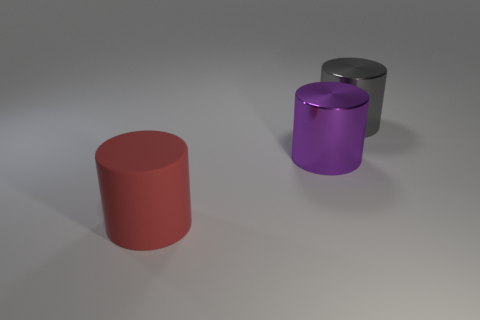Can you describe the colors and shapes present in this image? Certainly! There are three cylindrical objects in the image. Starting from the left, the first one is red with a matte finish, the middle one is purple with a glossy sheen, and the one on the right is gray, also with a shiny surface. They all have circular bases and stand upright, but the red and gray cylinders are shorter than the purple one.  What can you infer about the material of the objects? Based on their appearance, the objects seem to be made of a smooth, perhaps metallic material, as indicated by the reflections and the polished surfaces, especially noticeable on the purple and gray cylinders which exhibit a high level of sheen. 